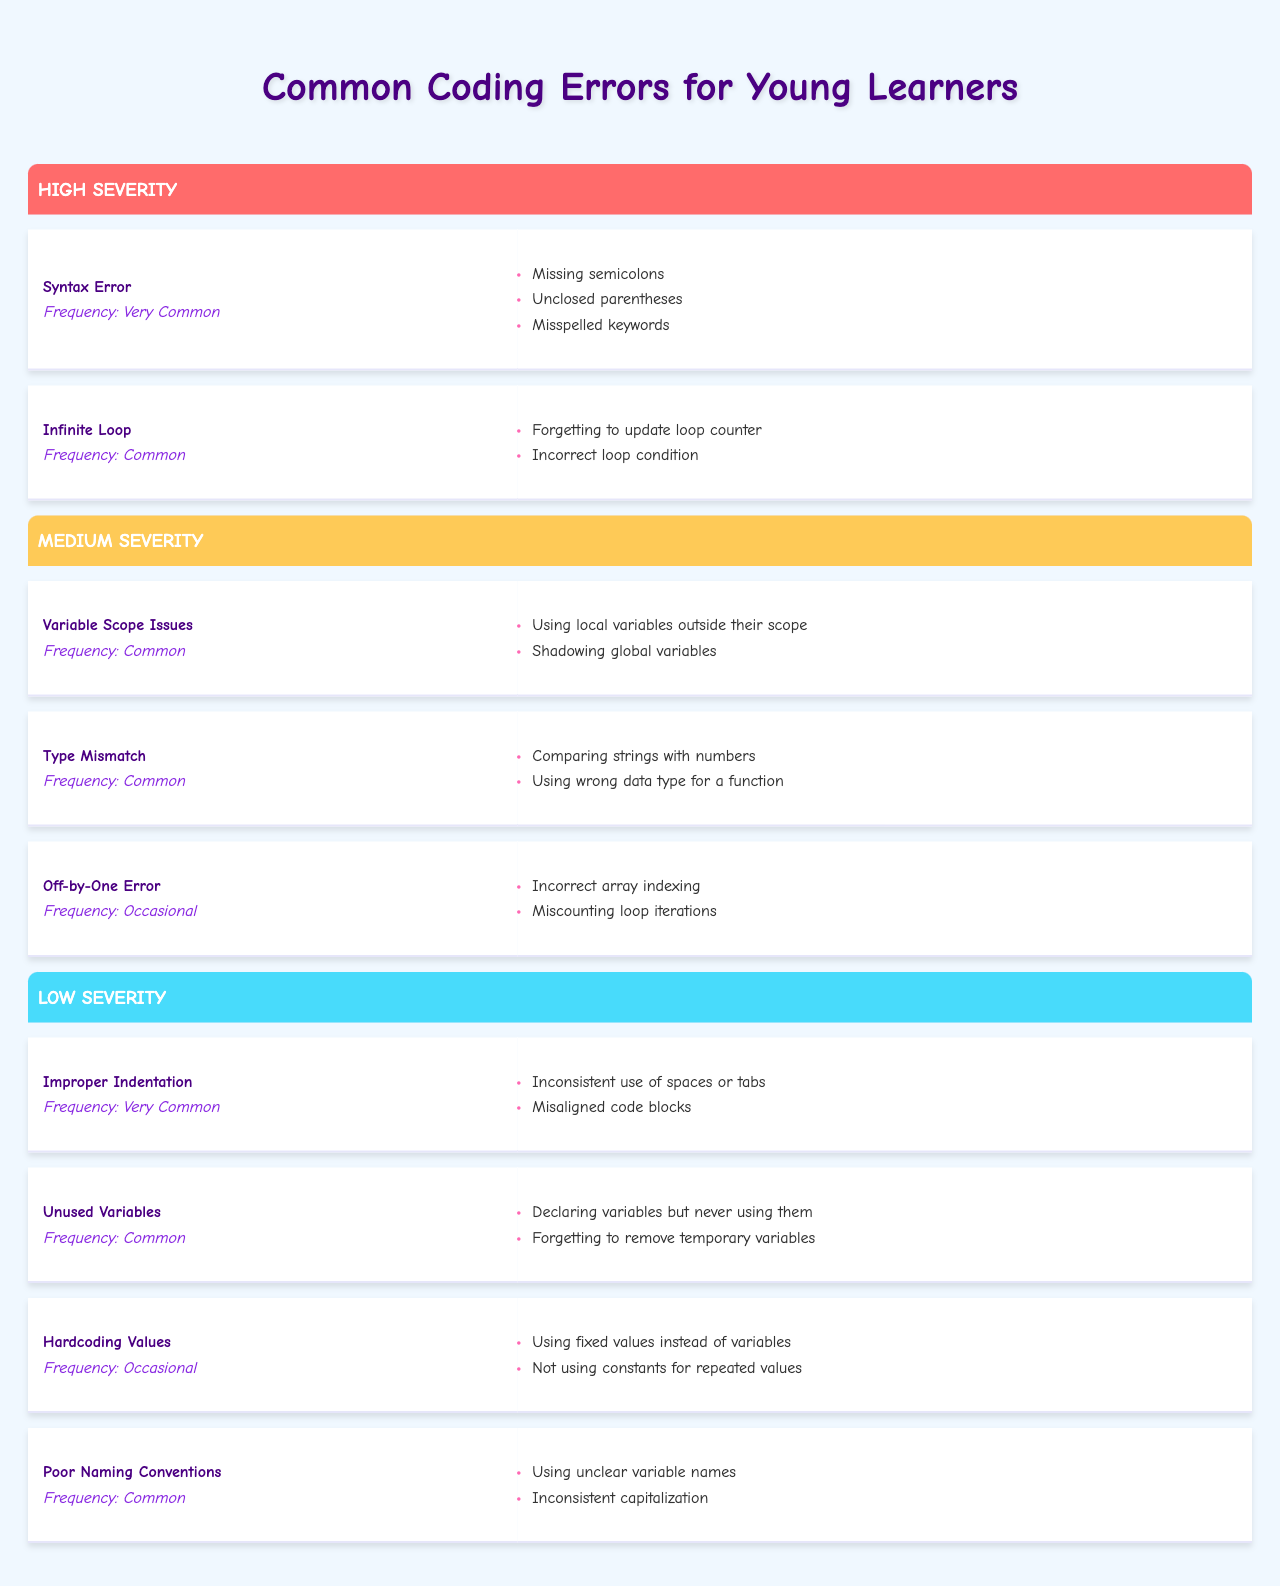What is the most severe coding error listed in the table? The highest severity level in the table is "High," which includes "Syntax Error" and "Infinite Loop." The most severe error is therefore "Syntax Error."
Answer: Syntax Error How many coding errors are categorized as having low severity? From the low severity section, there are four errors listed: "Improper Indentation," "Unused Variables," "Hardcoding Values," and "Poor Naming Conventions." Thus, the count is four.
Answer: 4 Which error has a frequency of "Very Common"? In the table, "Syntax Error" and "Improper Indentation" are both categorized as "Very Common."
Answer: Syntax Error and Improper Indentation What is the frequency of "Type Mismatch"? The table states that "Type Mismatch" has a frequency of "Common."
Answer: Common Are there any coding errors that have "Occasional" frequency in the low severity category? Yes, "Hardcoding Values" has an "Occasional" frequency and is located under the low severity category.
Answer: Yes How many errors are considered "Common"? There are five errors marked as "Common": "Infinite Loop," "Variable Scope Issues," "Type Mismatch," "Unused Variables," and "Poor Naming Conventions," making a total of five.
Answer: 5 Which coding error has a higher severity: "Variable Scope Issues" or "Infinite Loop"? "Variable Scope Issues" has a severity of "Medium" while "Infinite Loop" has "High" severity. Since "High" is more severe than "Medium," "Infinite Loop" is the higher severity error.
Answer: Infinite Loop Is "Improper Indentation" considered a high severity error? No, "Improper Indentation" is categorized under low severity.
Answer: No What is the total number of coding errors listed in the "Medium" severity category? There are three errors listed under medium severity: "Variable Scope Issues," "Type Mismatch," and "Off-by-One Error," totaling three errors.
Answer: 3 Which error has the lowest frequency listed in the table? "Off-by-One Error" and "Hardcoding Values" are both noted as "Occasional," which denotes the lowest frequency compared to others.
Answer: Off-by-One Error and Hardcoding Values How does the frequency of "Unused Variables" compare to "Infinite Loop"? "Unused Variables" is listed with a frequency of "Common," while "Infinite Loop" has a frequency of "Common" as well. They are the same in frequency.
Answer: They are the same 